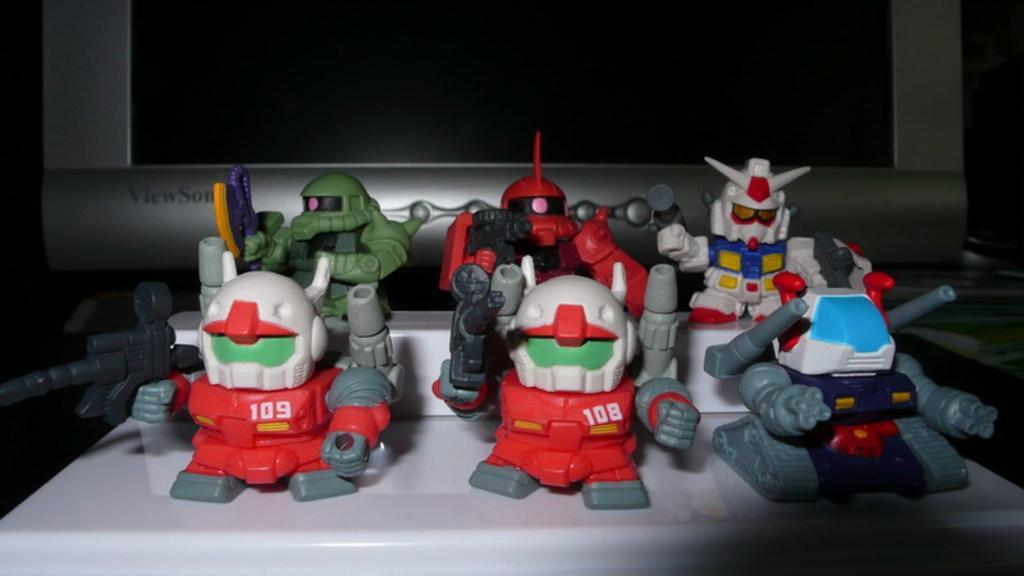Can you describe this image briefly? In this image, there are toys on an object and I can see a monitor. The background is dark. 